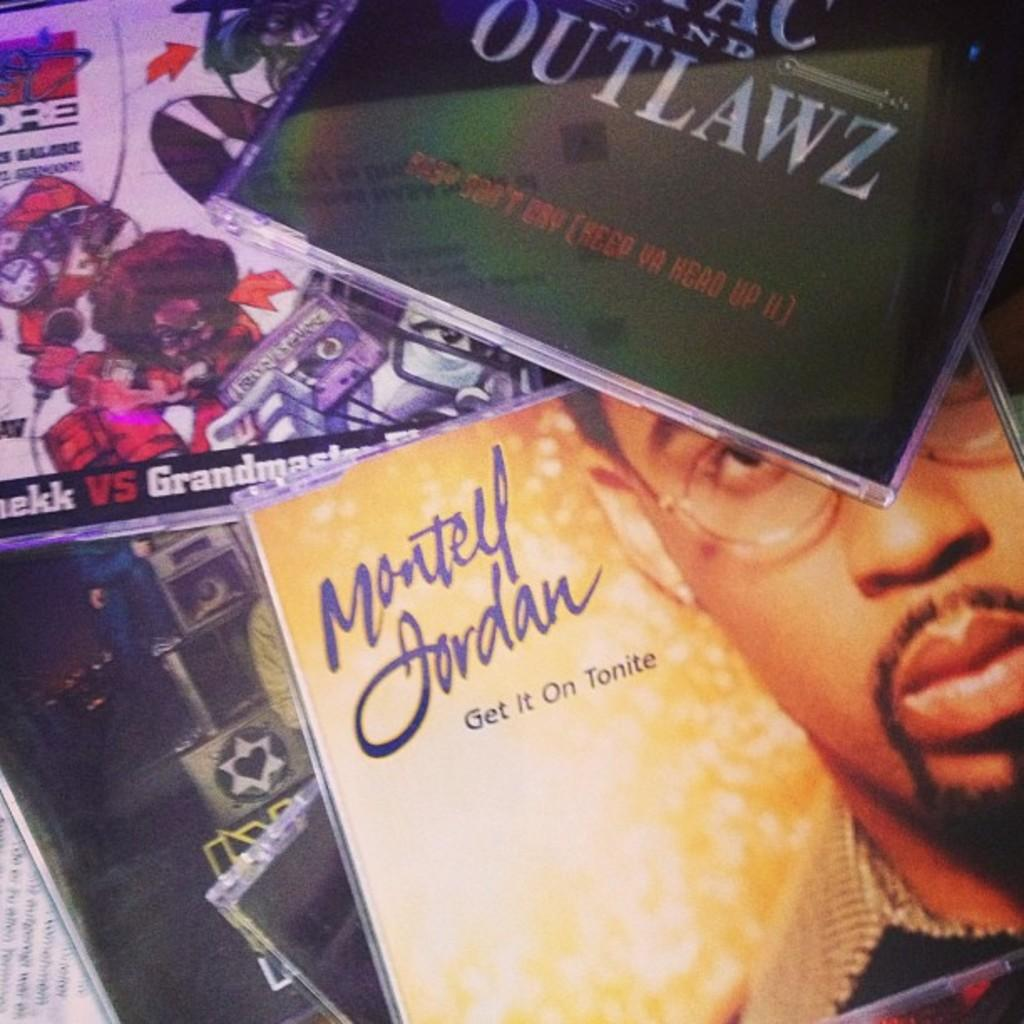Provide a one-sentence caption for the provided image. The CD collection includes Montell Jordan's Get it On Tonite. 